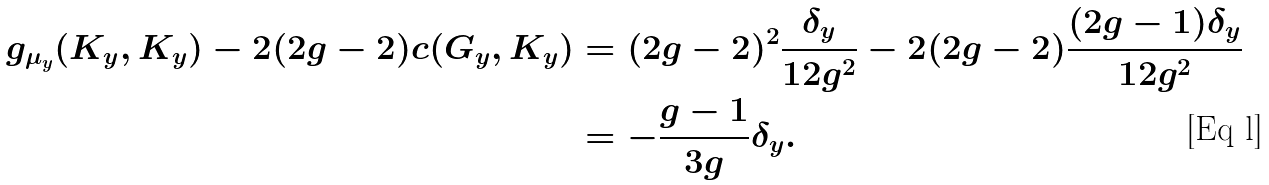<formula> <loc_0><loc_0><loc_500><loc_500>g _ { \mu _ { y } } ( K _ { y } , K _ { y } ) - 2 ( 2 g - 2 ) c ( G _ { y } , K _ { y } ) & = ( 2 g - 2 ) ^ { 2 } \frac { \delta _ { y } } { 1 2 g ^ { 2 } } - 2 ( 2 g - 2 ) \frac { ( 2 g - 1 ) \delta _ { y } } { 1 2 g ^ { 2 } } \\ & = - \frac { g - 1 } { 3 g } \delta _ { y } .</formula> 